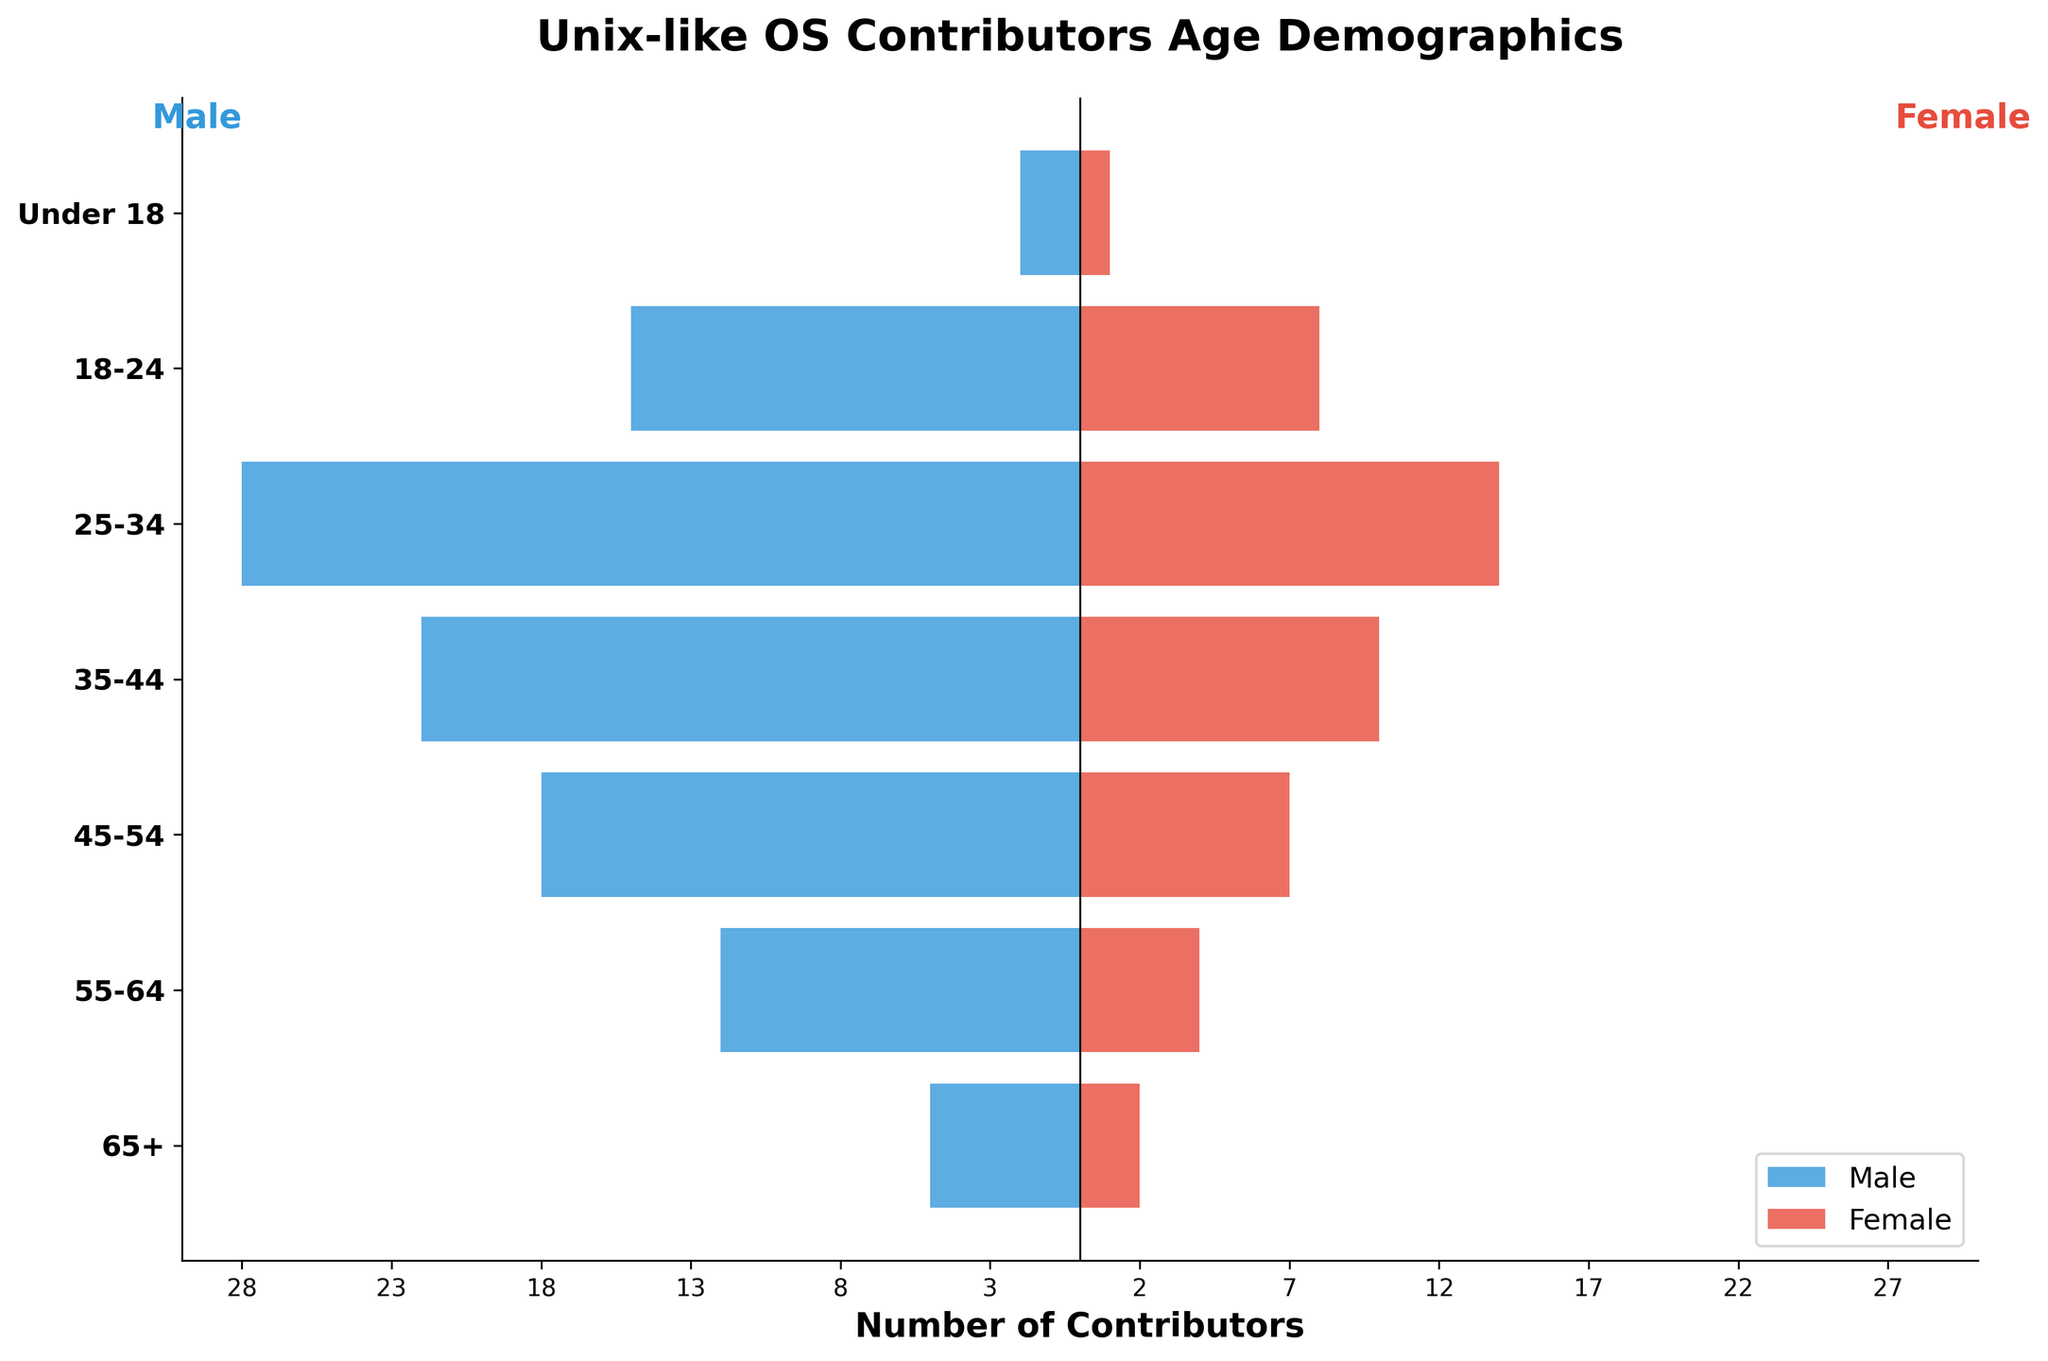what is the age group with the highest number of male contributors? Look for the longest bar on the male (left) side of the pyramid. The longest bar is for the age group "25-34".
Answer: 25-34 Which gender has more contributors in the "35-44" age group? Compare the lengths of the bars for males and females in the "35-44" age group. The male bar is longer than the female bar.
Answer: Male What is the sum of male and female contributors in the "55-64" age group? Add the number of male contributors (12) and female contributors (4) in the "55-64" age group. 12 + 4 = 16
Answer: 16 Which age group has exactly twice as many male contributors compared to female contributors? Look for an age group where the male bar is twice as long as the female bar. In the "55-64" age group, there are 12 male contributors and 4 female contributors, which fits the condition.
Answer: 55-64 What is the total number of female contributors in all age groups? Sum the number of female contributors: 1 + 8 + 14 + 10 + 7 + 4 + 2. The total is 46.
Answer: 46 In which age group is the difference between the number of male and female contributors the greatest? Compute the absolute differences between male and female contributors across all age groups and find the maximum. The "25-34" age group has the highest difference:
Answer: 25-34 Which gender has more contributors in the "65+" age group, and by how many? Compare the lengths of the bars for males and females in the "65+" age group. Males have 5 contributors, females have 2 contributors. The difference is 3.
Answer: Male, by 3 What is the average number of male contributors across all age groups? Sum the number of male contributors and divide by the number of age groups: (2 + 15 + 28 + 22 + 18 + 12 + 5) / 7 = 14.57, approximately 15 when rounded.
Answer: 14.57 Which age group has the fewest total contributors? Sum the male and female contributors for each age group and identify the smallest total. The "Under 18" group has the fewest total with 2 + 1 = 3.
Answer: Under 18 How does the gender distribution in the "18-24" age group compare to the "45-54" age group? Compare the number of male and female contributors in the "18-24" (male: 15, female: 8) and "45-54" (male: 18, female: 7) age groups. Both groups have more male contributors, but the distribution differs slightly: 15/8 = 1.875 and 18/7 = 2.57.
Answer: Both groups are male-dominant; the ratio is slightly higher in "45-54" 